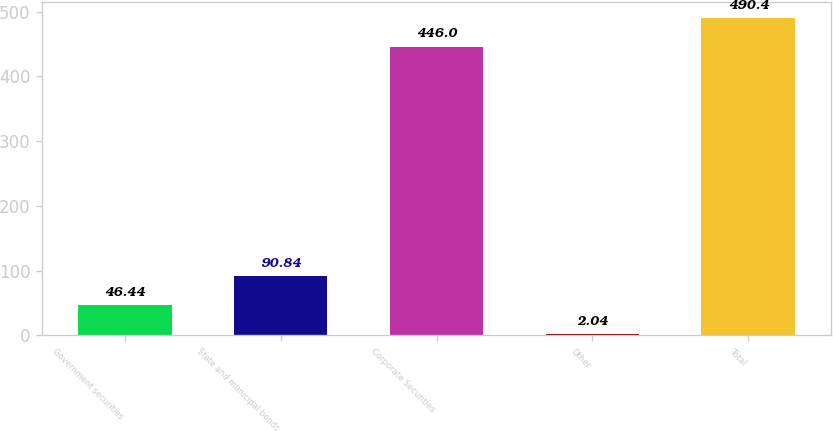Convert chart to OTSL. <chart><loc_0><loc_0><loc_500><loc_500><bar_chart><fcel>Government securities<fcel>State and municipal bonds<fcel>Corporate Securities<fcel>Other<fcel>Total<nl><fcel>46.44<fcel>90.84<fcel>446<fcel>2.04<fcel>490.4<nl></chart> 